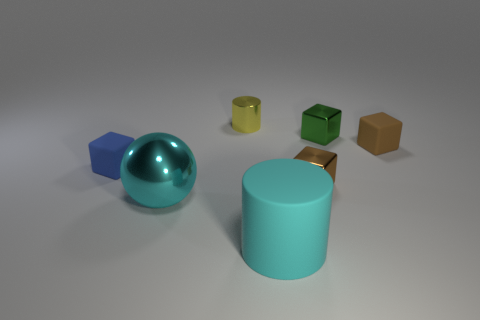Can you tell me the shapes of the objects near the front of the image? Near the front, there is a large teal cylinder and a reflective teal sphere. Are there any other notable features about these objects? Yes, the sphere is highly reflective, adding a unique visual interest by mirroring its surroundings subtly. The cylinder has a smooth finish and a soft color tone that complements the overall serene setup of the scene. 